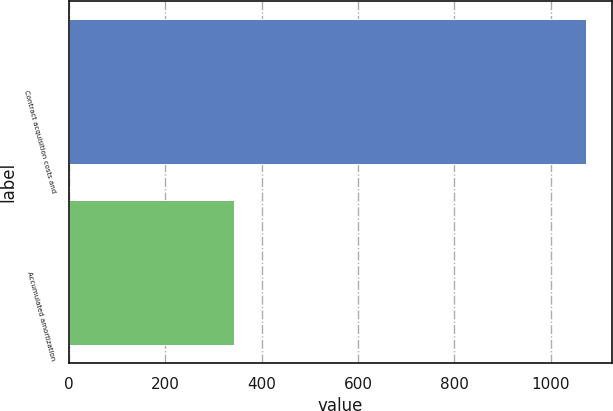Convert chart to OTSL. <chart><loc_0><loc_0><loc_500><loc_500><bar_chart><fcel>Contract acquisition costs and<fcel>Accumulated amortization<nl><fcel>1073<fcel>342<nl></chart> 